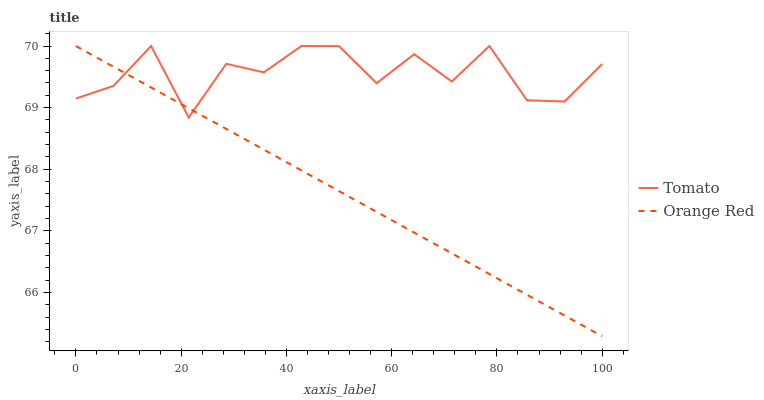Does Orange Red have the minimum area under the curve?
Answer yes or no. Yes. Does Tomato have the maximum area under the curve?
Answer yes or no. Yes. Does Orange Red have the maximum area under the curve?
Answer yes or no. No. Is Orange Red the smoothest?
Answer yes or no. Yes. Is Tomato the roughest?
Answer yes or no. Yes. Is Orange Red the roughest?
Answer yes or no. No. Does Orange Red have the lowest value?
Answer yes or no. Yes. Does Orange Red have the highest value?
Answer yes or no. Yes. Does Tomato intersect Orange Red?
Answer yes or no. Yes. Is Tomato less than Orange Red?
Answer yes or no. No. Is Tomato greater than Orange Red?
Answer yes or no. No. 